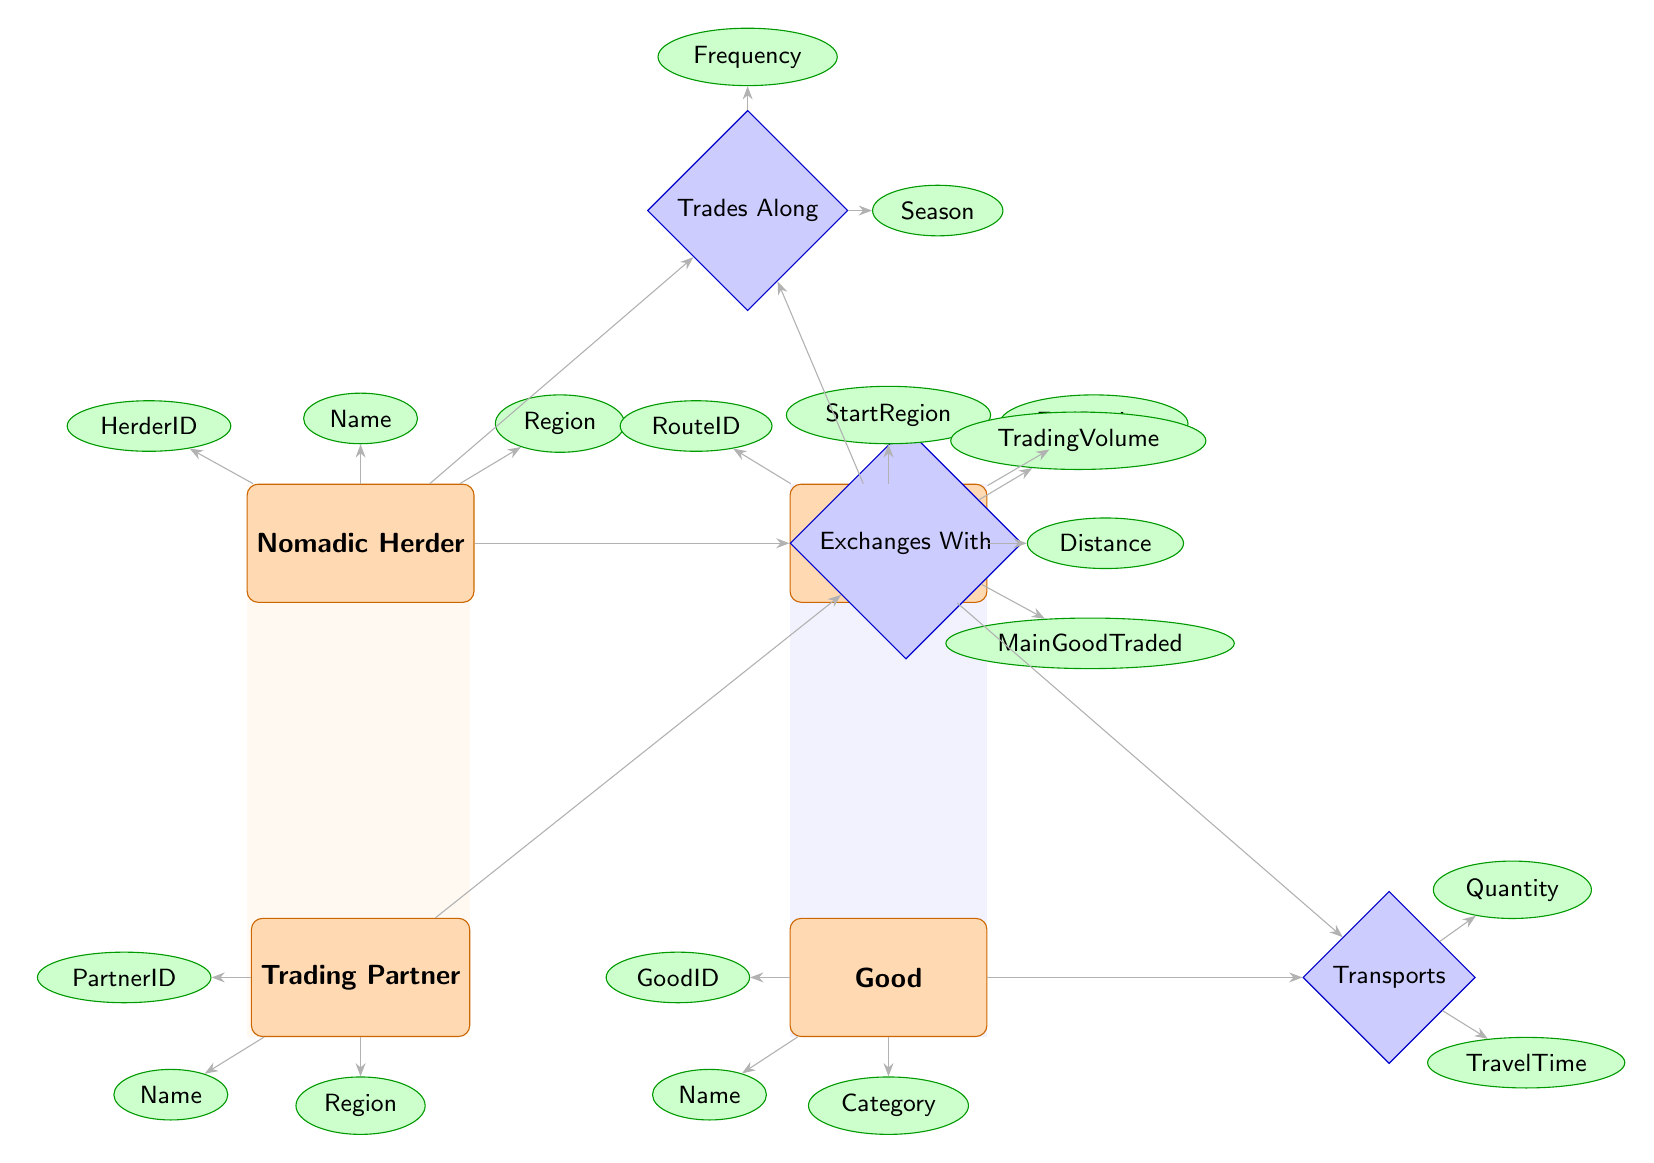What is the main good traded between a Nomadic Herder and a Trading Partner? The relationship "Exchanges With" connects a Nomadic Herder to a Trading Partner. This relationship has the attribute "MainGoodTraded," which explicitly indicates the primary item exchanged.
Answer: MainGoodTraded How many attributes does the Trade Route entity have? The Trade Route entity has four attributes: RouteID, StartRegion, EndRegion, and Distance. Counting these gives us the total.
Answer: 4 What is the maximum number of trading partners a Nomadic Herder can have? The Nomadic Herder is connected to the Trading Partner through the "Exchanges With" relationship. There are no specified limits, and thus it is only constrained by the number of partners that could exist in the system.
Answer: Unlimited What attributes are associated with the Trades Along relationship? The Trades Along relationship connects Nomadic Herder and Trade Route. The associated attributes are Frequency and Season, which describe how frequently and during which time of year trade occurs.
Answer: Frequency, Season Which entity has the attribute 'Quantity'? The attribute 'Quantity' is linked to the "Transports" relationship, which connects Trade Route with Good. Therefore, it is the Good entity that has this attribute related to transport capacity.
Answer: Good Which relationship indicates how many times a Nomadic Herder uses a Trade Route? The relationship "Trades Along" explicitly measures the interaction frequency between a Nomadic Herder and a Trade Route, thus indicating the number of times the route is utilized for trading.
Answer: Trades Along In what regions can the Trading Partners be located? The Trading Partner entity has the attribute Region, which identifies the geographical location of the trading partners. Therefore, the Trading Partners can be located in any regions specified by the data.
Answer: Any Region What is the distance relation between Trade Route and its associated entities? The Trade Route entity includes the Distance attribute, which reflects the length of the route between StartRegion and EndRegion. This provides a spatial understanding of trade logistics.
Answer: Distance 